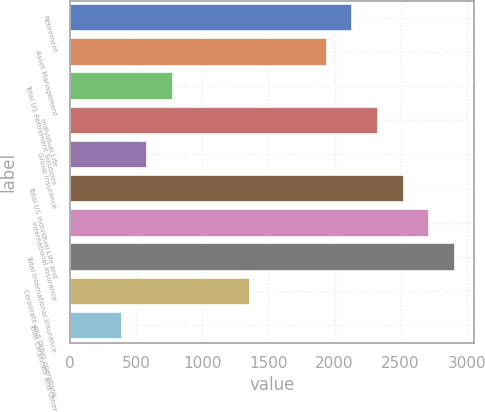Convert chart to OTSL. <chart><loc_0><loc_0><loc_500><loc_500><bar_chart><fcel>Retirement<fcel>Asset Management<fcel>Total US Retirement Solutions<fcel>Individual Life<fcel>Group Insurance<fcel>Total US Individual Life and<fcel>International Insurance<fcel>Total International Insurance<fcel>Corporate and Other operations<fcel>Total Corporate and Other<nl><fcel>2135.09<fcel>1941.03<fcel>776.67<fcel>2329.15<fcel>582.61<fcel>2523.21<fcel>2717.27<fcel>2911.33<fcel>1358.85<fcel>388.55<nl></chart> 